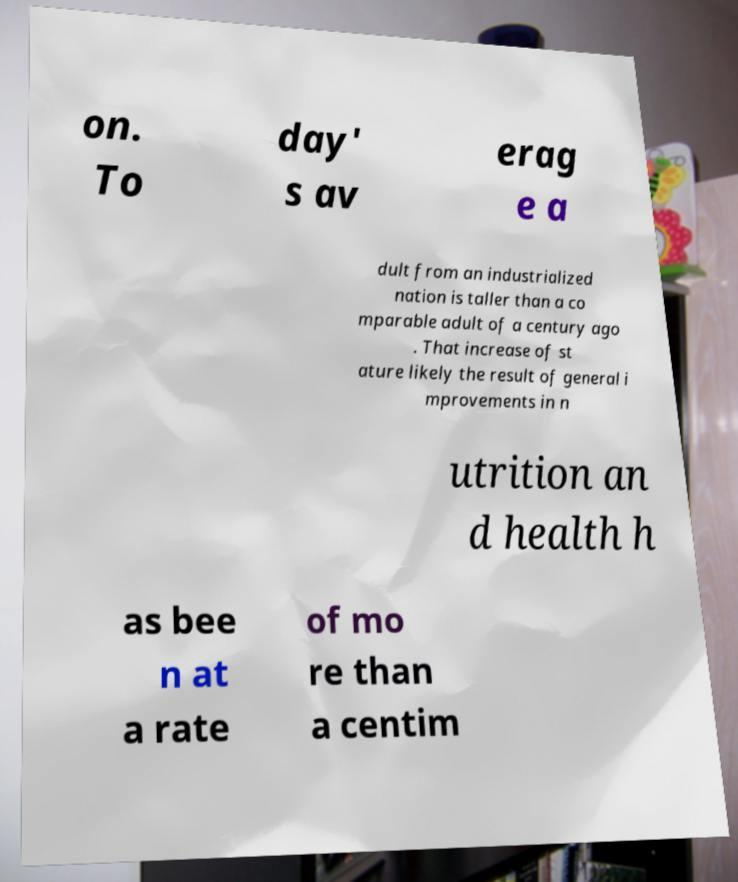Please read and relay the text visible in this image. What does it say? on. To day' s av erag e a dult from an industrialized nation is taller than a co mparable adult of a century ago . That increase of st ature likely the result of general i mprovements in n utrition an d health h as bee n at a rate of mo re than a centim 